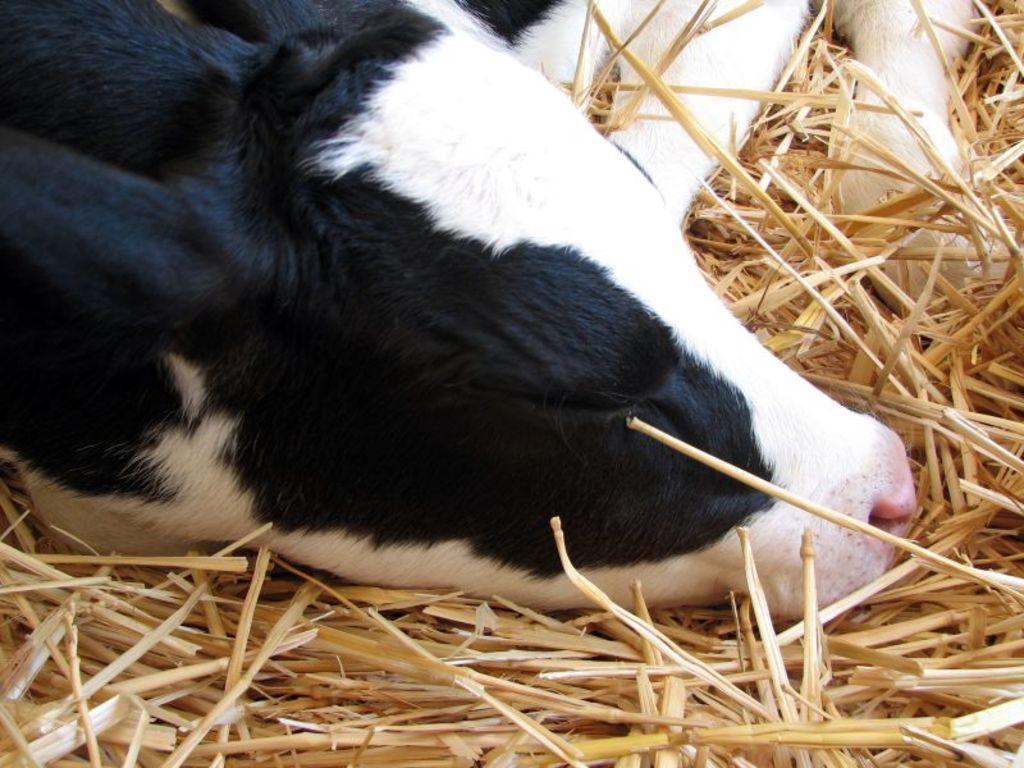Describe this image in one or two sentences. In this image we can see an animal sleeping on the lawn straw. 